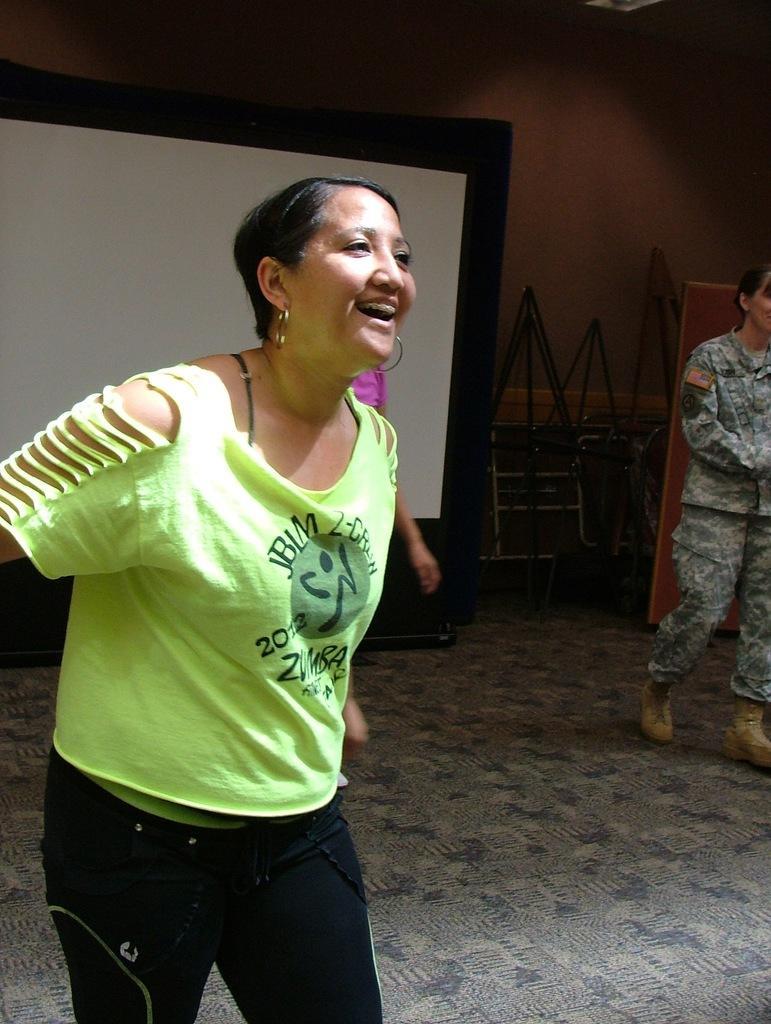Can you describe this image briefly? This picture shows couple of women walking and we see screen and another human on the back and we see smile on the face of a woman and she wore a green color t-shirt and black color trouser. 